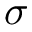<formula> <loc_0><loc_0><loc_500><loc_500>\sigma</formula> 